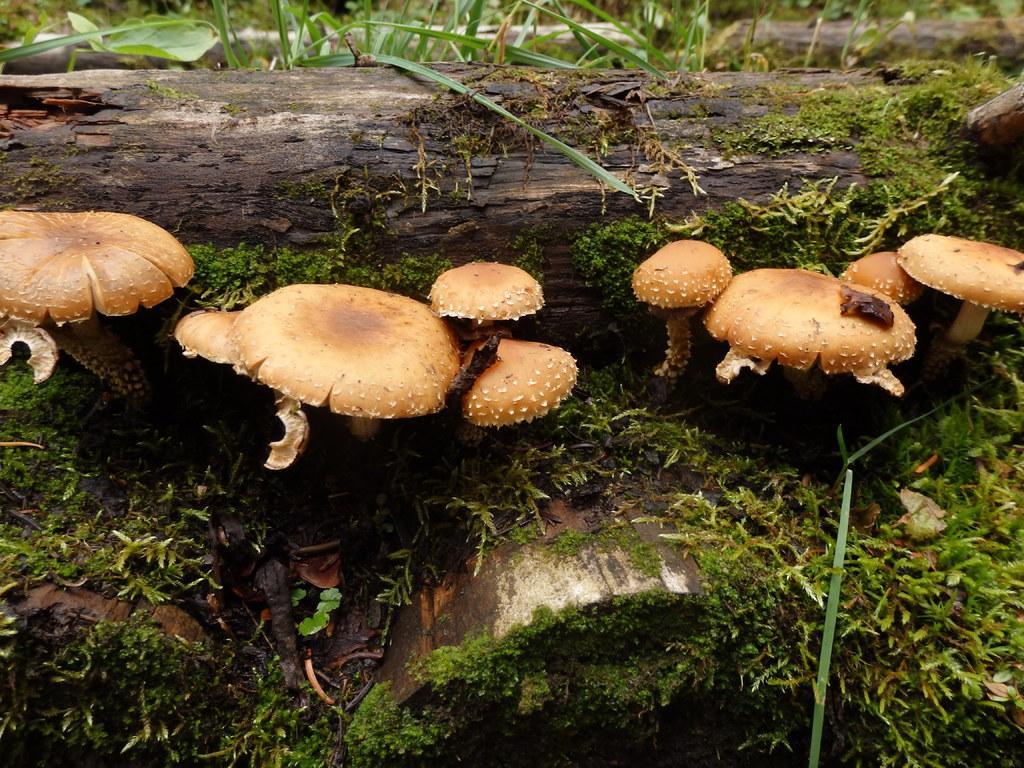Describe this image in one or two sentences. In this image I see the mushrooms and I see the plants and I see the wood over here and I see the algae which is of green in color. 